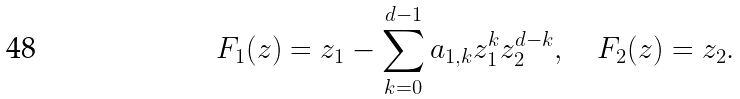<formula> <loc_0><loc_0><loc_500><loc_500>F _ { 1 } ( z ) = z _ { 1 } - \sum _ { k = 0 } ^ { d - 1 } a _ { 1 , k } z _ { 1 } ^ { k } z _ { 2 } ^ { d - k } , \quad F _ { 2 } ( z ) = z _ { 2 } .</formula> 